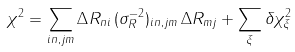<formula> <loc_0><loc_0><loc_500><loc_500>\chi ^ { 2 } = \sum _ { i n , j m } \Delta R _ { n i } \, ( \sigma ^ { - 2 } _ { R } ) _ { i n , j m } \, \Delta R _ { m j } + \sum _ { \xi } \delta \chi ^ { 2 } _ { \xi }</formula> 